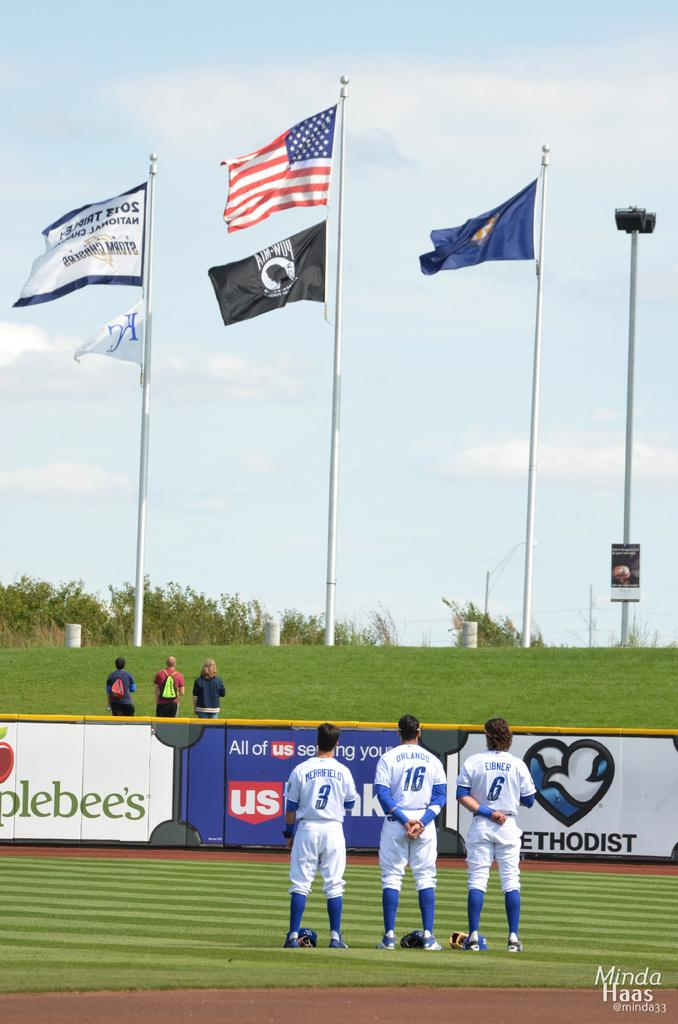<image>
Present a compact description of the photo's key features. A US Bank ad can be seen in a baseball stadium. 